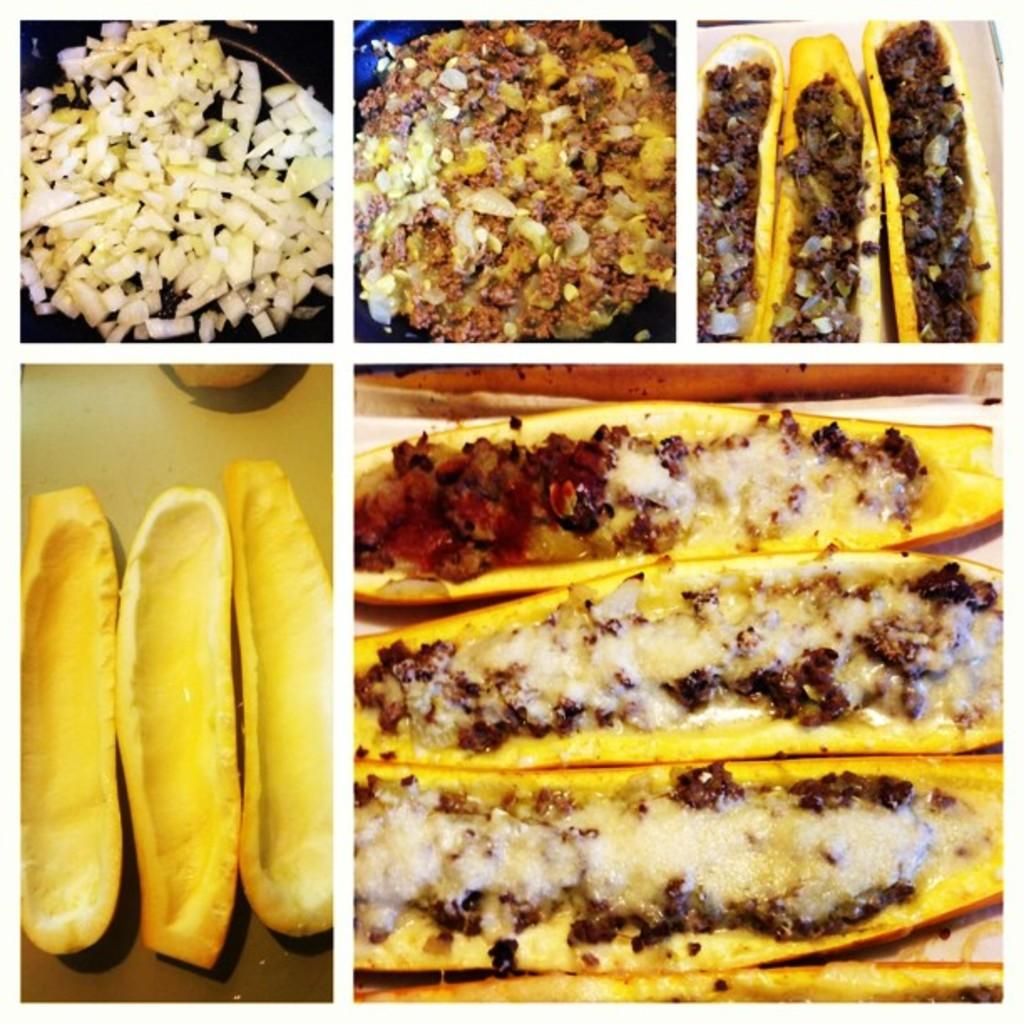What type of artwork is the image? The image is a collage. What can be found among the various elements in the collage? There are food items in the image. What might be used to serve the food items in the collage? There are plates in the image. How many pizzas are hanging from the neck of the person in the image? There is no person or pizzas present in the image; it is a collage featuring food items and plates. 